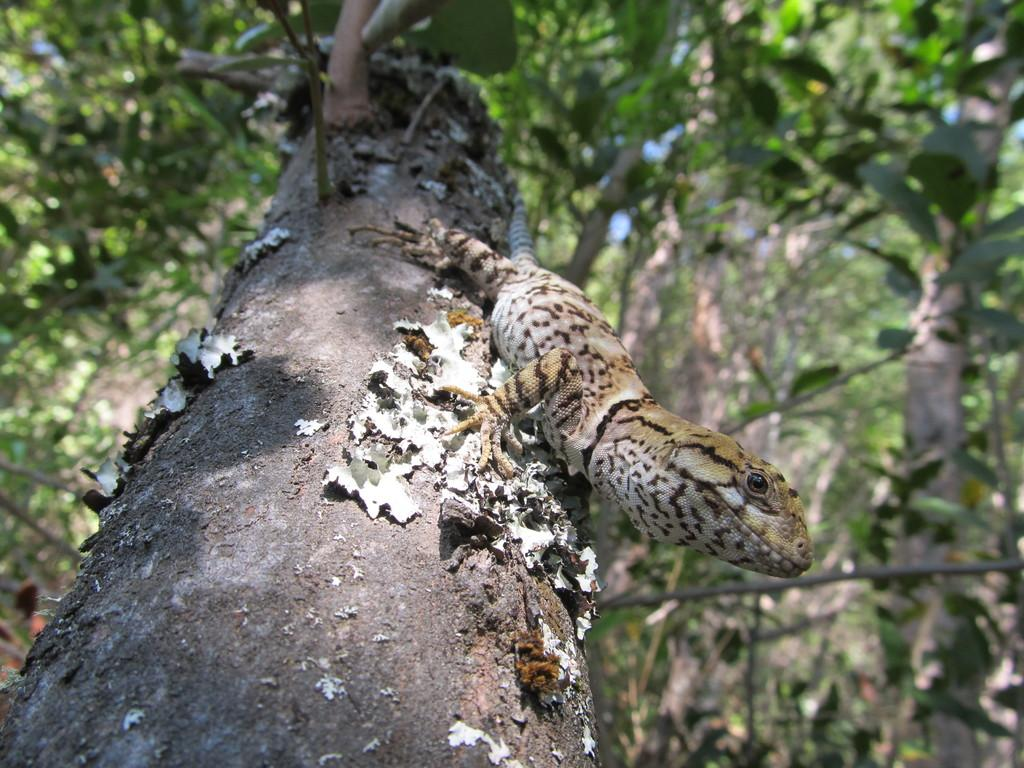What type of animal is in the picture? There is a Blue-tongued skink in the picture. Where is the skink located? The skink is on a tree trunk. What can be seen in the background of the image? There are other trees in the background of the image. What type of glove is the skink wearing in the image? There is no glove present in the image; the skink is an animal and does not wear gloves. 